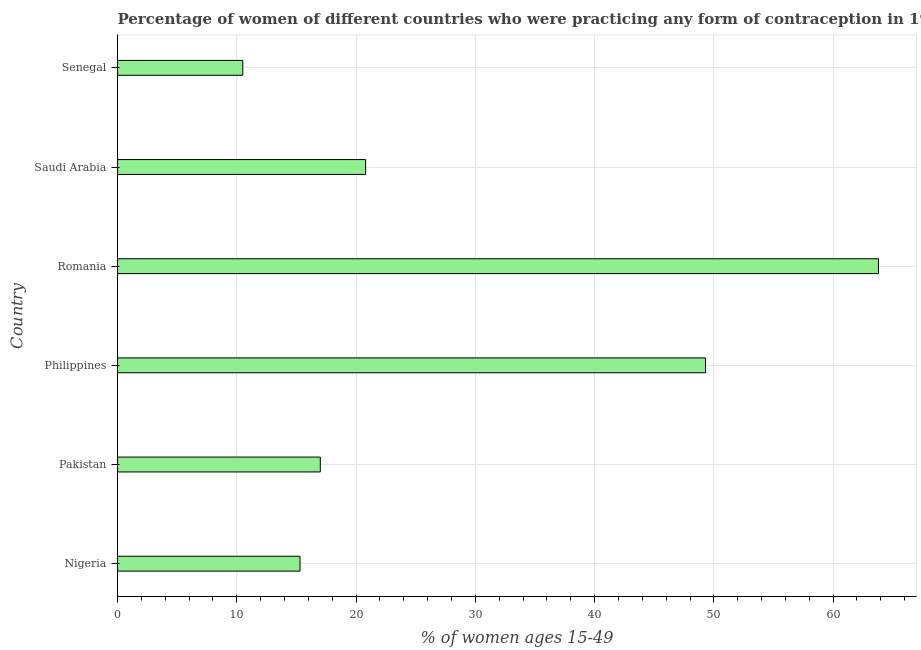Does the graph contain any zero values?
Offer a terse response. No. What is the title of the graph?
Keep it short and to the point. Percentage of women of different countries who were practicing any form of contraception in 1999. What is the label or title of the X-axis?
Keep it short and to the point. % of women ages 15-49. Across all countries, what is the maximum contraceptive prevalence?
Provide a short and direct response. 63.8. Across all countries, what is the minimum contraceptive prevalence?
Your response must be concise. 10.5. In which country was the contraceptive prevalence maximum?
Your answer should be compact. Romania. In which country was the contraceptive prevalence minimum?
Ensure brevity in your answer.  Senegal. What is the sum of the contraceptive prevalence?
Provide a succinct answer. 176.7. What is the difference between the contraceptive prevalence in Romania and Saudi Arabia?
Provide a short and direct response. 43. What is the average contraceptive prevalence per country?
Keep it short and to the point. 29.45. What is the median contraceptive prevalence?
Your answer should be compact. 18.9. In how many countries, is the contraceptive prevalence greater than 58 %?
Ensure brevity in your answer.  1. What is the ratio of the contraceptive prevalence in Nigeria to that in Romania?
Offer a terse response. 0.24. Is the difference between the contraceptive prevalence in Nigeria and Senegal greater than the difference between any two countries?
Ensure brevity in your answer.  No. What is the difference between the highest and the second highest contraceptive prevalence?
Keep it short and to the point. 14.5. What is the difference between the highest and the lowest contraceptive prevalence?
Provide a short and direct response. 53.3. In how many countries, is the contraceptive prevalence greater than the average contraceptive prevalence taken over all countries?
Your response must be concise. 2. How many countries are there in the graph?
Your answer should be compact. 6. What is the difference between two consecutive major ticks on the X-axis?
Make the answer very short. 10. What is the % of women ages 15-49 in Pakistan?
Offer a very short reply. 17. What is the % of women ages 15-49 in Philippines?
Offer a terse response. 49.3. What is the % of women ages 15-49 in Romania?
Offer a terse response. 63.8. What is the % of women ages 15-49 in Saudi Arabia?
Give a very brief answer. 20.8. What is the % of women ages 15-49 of Senegal?
Offer a terse response. 10.5. What is the difference between the % of women ages 15-49 in Nigeria and Philippines?
Make the answer very short. -34. What is the difference between the % of women ages 15-49 in Nigeria and Romania?
Your response must be concise. -48.5. What is the difference between the % of women ages 15-49 in Nigeria and Saudi Arabia?
Make the answer very short. -5.5. What is the difference between the % of women ages 15-49 in Nigeria and Senegal?
Provide a succinct answer. 4.8. What is the difference between the % of women ages 15-49 in Pakistan and Philippines?
Provide a short and direct response. -32.3. What is the difference between the % of women ages 15-49 in Pakistan and Romania?
Your response must be concise. -46.8. What is the difference between the % of women ages 15-49 in Philippines and Senegal?
Provide a short and direct response. 38.8. What is the difference between the % of women ages 15-49 in Romania and Saudi Arabia?
Ensure brevity in your answer.  43. What is the difference between the % of women ages 15-49 in Romania and Senegal?
Your answer should be compact. 53.3. What is the ratio of the % of women ages 15-49 in Nigeria to that in Philippines?
Ensure brevity in your answer.  0.31. What is the ratio of the % of women ages 15-49 in Nigeria to that in Romania?
Your response must be concise. 0.24. What is the ratio of the % of women ages 15-49 in Nigeria to that in Saudi Arabia?
Offer a very short reply. 0.74. What is the ratio of the % of women ages 15-49 in Nigeria to that in Senegal?
Ensure brevity in your answer.  1.46. What is the ratio of the % of women ages 15-49 in Pakistan to that in Philippines?
Your response must be concise. 0.34. What is the ratio of the % of women ages 15-49 in Pakistan to that in Romania?
Provide a succinct answer. 0.27. What is the ratio of the % of women ages 15-49 in Pakistan to that in Saudi Arabia?
Ensure brevity in your answer.  0.82. What is the ratio of the % of women ages 15-49 in Pakistan to that in Senegal?
Keep it short and to the point. 1.62. What is the ratio of the % of women ages 15-49 in Philippines to that in Romania?
Your response must be concise. 0.77. What is the ratio of the % of women ages 15-49 in Philippines to that in Saudi Arabia?
Provide a short and direct response. 2.37. What is the ratio of the % of women ages 15-49 in Philippines to that in Senegal?
Keep it short and to the point. 4.7. What is the ratio of the % of women ages 15-49 in Romania to that in Saudi Arabia?
Give a very brief answer. 3.07. What is the ratio of the % of women ages 15-49 in Romania to that in Senegal?
Your answer should be very brief. 6.08. What is the ratio of the % of women ages 15-49 in Saudi Arabia to that in Senegal?
Give a very brief answer. 1.98. 